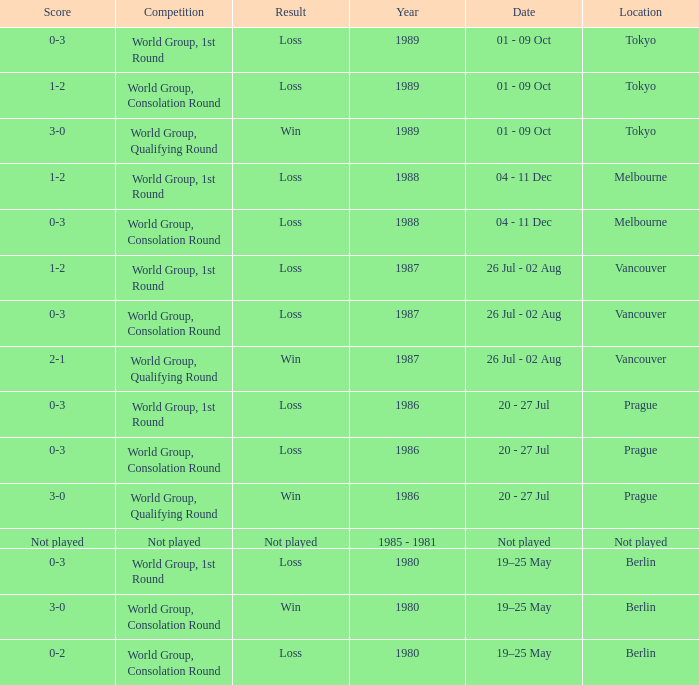What is the score when the result is loss, the year is 1980 and the competition is world group, consolation round? 0-2. 